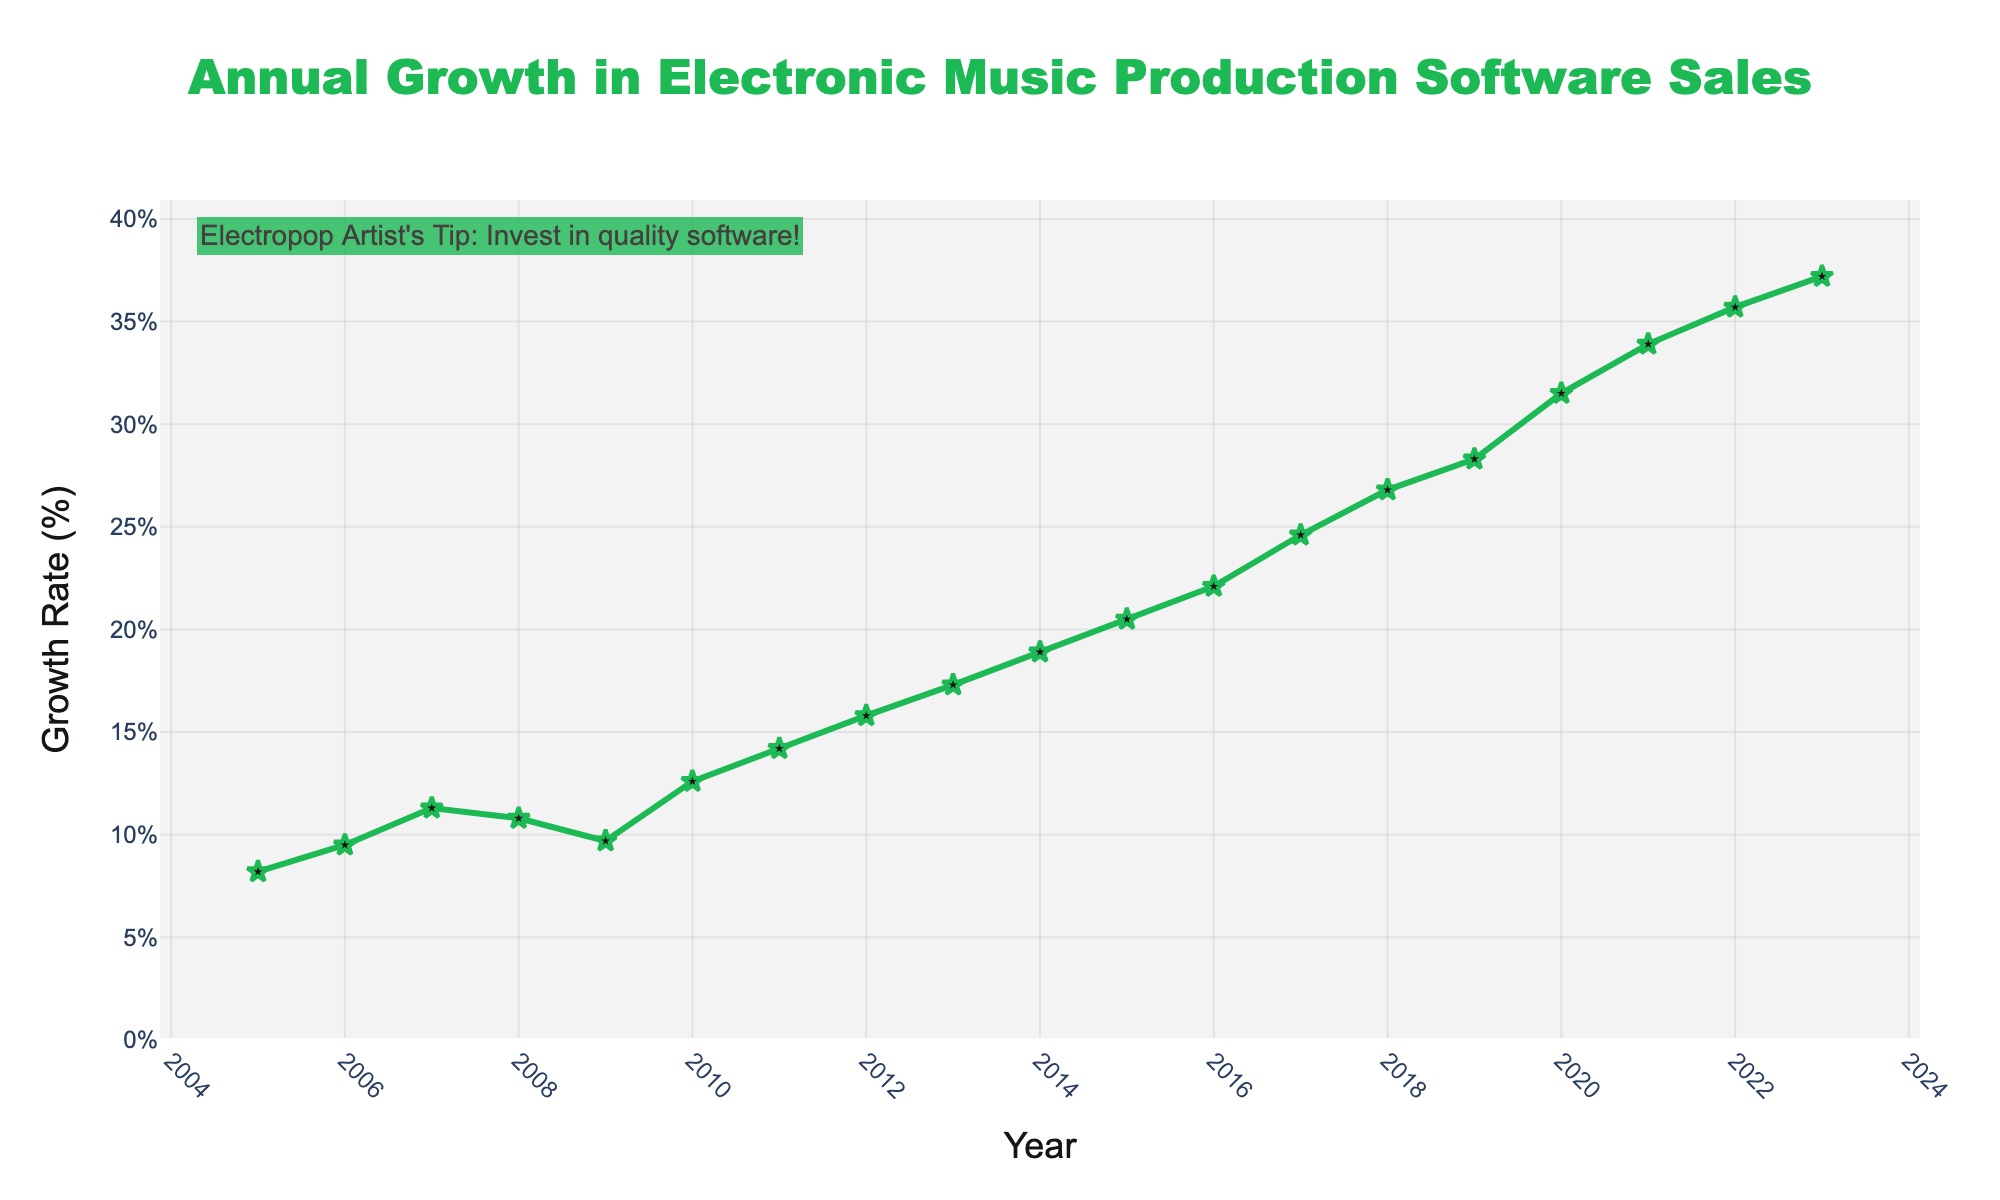What’s the growth rate in 2020? Locate the year 2020 on the x-axis and read off the corresponding growth rate on the y-axis, which shows 31.5%.
Answer: 31.5% How much has the growth rate increased from 2010 to 2023? Find the values for 2010 (12.6%) and 2023 (37.2%) from the figure. Compute the difference: 37.2% - 12.6% = 24.6%.
Answer: 24.6% Which year experienced the highest annual growth rate? Look at the point with the highest position along the y-axis, which corresponds to the growth rate in the year 2023.
Answer: 2023 How does the growth rate in 2016 compare to the growth rate in 2008? Find the growth rates for 2016 (22.1%) and 2008 (10.8%) from the figure. Compare them: 22.1% > 10.8%.
Answer: 2016 > 2008 What is the average annual growth rate from 2005 to 2010? Extract the data points for each year from 2005 to 2010 (8.2%, 9.5%, 11.3%, 10.8%, 9.7%, 12.6%). Add these values and divide by the number of data points: (8.2 + 9.5 + 11.3 + 10.8 + 9.7 + 12.6) / 6 = 10.35%.
Answer: 10.35% Which years have growth rates exceeding 25%? Identify the points where the y-axis value is greater than 25%. These occur in years 2017 (24.6%, close to but less than 25%), 2018 (26.8%), 2019 (28.3%), 2020 (31.5%), 2021 (33.9%), 2022 (35.7%), and 2023 (37.2%). 'Exceeding 25%' excludes 2017.
Answer: 2018, 2019, 2020, 2021, 2022, 2023 What is the trend in growth rates from 2005 to 2023? Observing the figure, the growth rate consistently increases over time, indicating a steady upward trend.
Answer: Increasing Identify any years where the growth rate decreased compared to the previous year. Scan sequentially through the data points: from 2007 (11.3%) to 2008 (10.8%). This is where a decrease is observed.
Answer: 2008 What is the median growth rate between 2015 and 2020? List the growth rates for these years: 20.5%, 22.1%, 24.6%, 26.8%, 28.3%, 31.5%. The median is the middle value in an ordered list. For 6 numbers, the median is the average of the 3rd and 4th values: (24.6% + 26.8%) / 2 = 25.7%.
Answer: 25.7% How much did the growth rate change between the year with the highest growth rate and the year with the lowest growth rate? The highest growth rate is in 2023 (37.2%) and the lowest in 2005 (8.2%). Calculate the difference: 37.2% - 8.2% = 29%.
Answer: 29% 